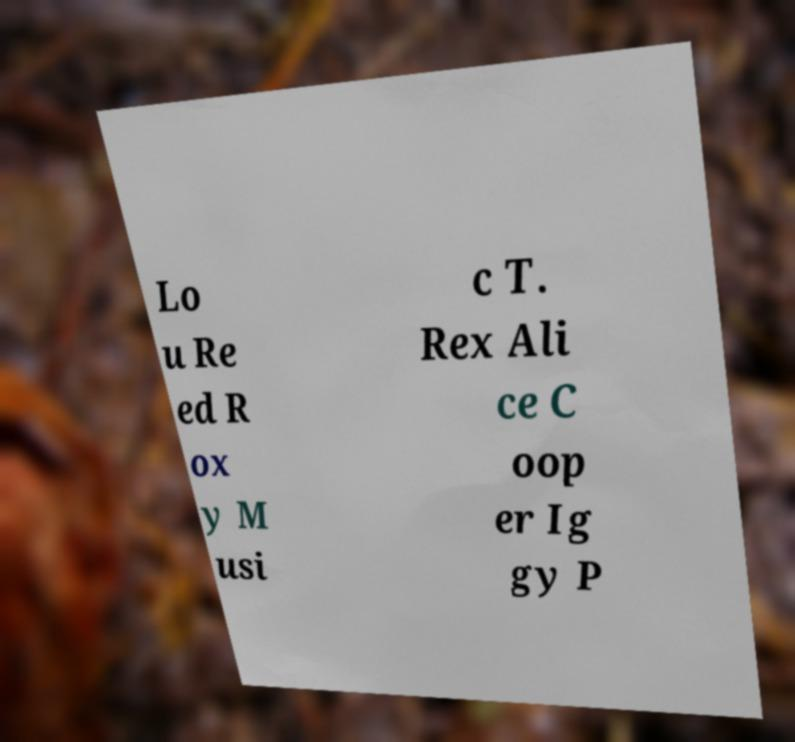Could you assist in decoding the text presented in this image and type it out clearly? Lo u Re ed R ox y M usi c T. Rex Ali ce C oop er Ig gy P 